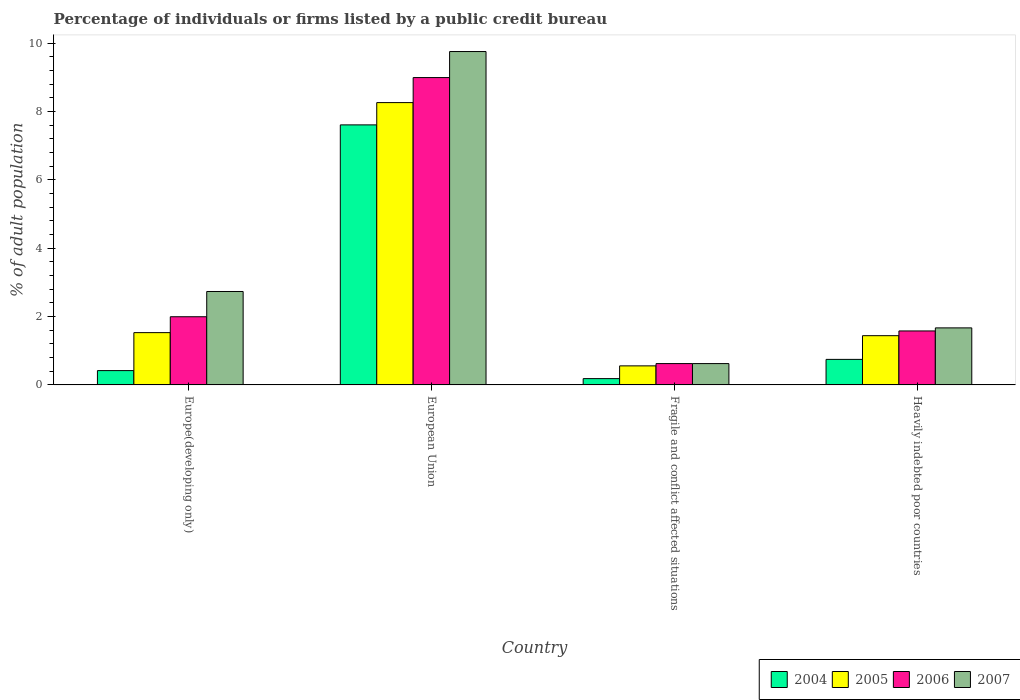How many different coloured bars are there?
Your answer should be very brief. 4. Are the number of bars per tick equal to the number of legend labels?
Your answer should be compact. Yes. What is the label of the 1st group of bars from the left?
Provide a succinct answer. Europe(developing only). What is the percentage of population listed by a public credit bureau in 2007 in Europe(developing only)?
Your response must be concise. 2.73. Across all countries, what is the maximum percentage of population listed by a public credit bureau in 2005?
Offer a very short reply. 8.26. Across all countries, what is the minimum percentage of population listed by a public credit bureau in 2004?
Keep it short and to the point. 0.18. In which country was the percentage of population listed by a public credit bureau in 2007 minimum?
Provide a succinct answer. Fragile and conflict affected situations. What is the total percentage of population listed by a public credit bureau in 2006 in the graph?
Offer a very short reply. 13.19. What is the difference between the percentage of population listed by a public credit bureau in 2005 in Europe(developing only) and that in Fragile and conflict affected situations?
Make the answer very short. 0.97. What is the difference between the percentage of population listed by a public credit bureau in 2007 in Europe(developing only) and the percentage of population listed by a public credit bureau in 2005 in European Union?
Your answer should be compact. -5.53. What is the average percentage of population listed by a public credit bureau in 2006 per country?
Offer a very short reply. 3.3. What is the difference between the percentage of population listed by a public credit bureau of/in 2005 and percentage of population listed by a public credit bureau of/in 2007 in European Union?
Your answer should be compact. -1.49. What is the ratio of the percentage of population listed by a public credit bureau in 2005 in Europe(developing only) to that in European Union?
Your answer should be compact. 0.19. Is the difference between the percentage of population listed by a public credit bureau in 2005 in European Union and Heavily indebted poor countries greater than the difference between the percentage of population listed by a public credit bureau in 2007 in European Union and Heavily indebted poor countries?
Provide a succinct answer. No. What is the difference between the highest and the second highest percentage of population listed by a public credit bureau in 2004?
Provide a succinct answer. 0.33. What is the difference between the highest and the lowest percentage of population listed by a public credit bureau in 2006?
Keep it short and to the point. 8.37. In how many countries, is the percentage of population listed by a public credit bureau in 2006 greater than the average percentage of population listed by a public credit bureau in 2006 taken over all countries?
Provide a short and direct response. 1. Is the sum of the percentage of population listed by a public credit bureau in 2005 in Fragile and conflict affected situations and Heavily indebted poor countries greater than the maximum percentage of population listed by a public credit bureau in 2007 across all countries?
Make the answer very short. No. What does the 2nd bar from the left in European Union represents?
Keep it short and to the point. 2005. What does the 3rd bar from the right in Europe(developing only) represents?
Offer a terse response. 2005. Is it the case that in every country, the sum of the percentage of population listed by a public credit bureau in 2005 and percentage of population listed by a public credit bureau in 2007 is greater than the percentage of population listed by a public credit bureau in 2006?
Ensure brevity in your answer.  Yes. How many countries are there in the graph?
Offer a very short reply. 4. What is the difference between two consecutive major ticks on the Y-axis?
Provide a succinct answer. 2. Does the graph contain any zero values?
Provide a succinct answer. No. Where does the legend appear in the graph?
Your response must be concise. Bottom right. How are the legend labels stacked?
Your answer should be very brief. Horizontal. What is the title of the graph?
Your answer should be very brief. Percentage of individuals or firms listed by a public credit bureau. What is the label or title of the X-axis?
Keep it short and to the point. Country. What is the label or title of the Y-axis?
Make the answer very short. % of adult population. What is the % of adult population in 2004 in Europe(developing only)?
Your answer should be compact. 0.42. What is the % of adult population in 2005 in Europe(developing only)?
Keep it short and to the point. 1.53. What is the % of adult population of 2006 in Europe(developing only)?
Make the answer very short. 1.99. What is the % of adult population in 2007 in Europe(developing only)?
Ensure brevity in your answer.  2.73. What is the % of adult population in 2004 in European Union?
Give a very brief answer. 7.61. What is the % of adult population in 2005 in European Union?
Offer a very short reply. 8.26. What is the % of adult population in 2006 in European Union?
Offer a very short reply. 8.99. What is the % of adult population of 2007 in European Union?
Provide a short and direct response. 9.75. What is the % of adult population in 2004 in Fragile and conflict affected situations?
Ensure brevity in your answer.  0.18. What is the % of adult population in 2005 in Fragile and conflict affected situations?
Offer a very short reply. 0.56. What is the % of adult population of 2006 in Fragile and conflict affected situations?
Make the answer very short. 0.62. What is the % of adult population of 2007 in Fragile and conflict affected situations?
Your response must be concise. 0.62. What is the % of adult population of 2004 in Heavily indebted poor countries?
Keep it short and to the point. 0.75. What is the % of adult population in 2005 in Heavily indebted poor countries?
Offer a very short reply. 1.44. What is the % of adult population of 2006 in Heavily indebted poor countries?
Offer a very short reply. 1.58. What is the % of adult population of 2007 in Heavily indebted poor countries?
Offer a terse response. 1.67. Across all countries, what is the maximum % of adult population in 2004?
Your answer should be very brief. 7.61. Across all countries, what is the maximum % of adult population of 2005?
Offer a terse response. 8.26. Across all countries, what is the maximum % of adult population of 2006?
Ensure brevity in your answer.  8.99. Across all countries, what is the maximum % of adult population of 2007?
Make the answer very short. 9.75. Across all countries, what is the minimum % of adult population of 2004?
Keep it short and to the point. 0.18. Across all countries, what is the minimum % of adult population of 2005?
Offer a terse response. 0.56. Across all countries, what is the minimum % of adult population in 2006?
Ensure brevity in your answer.  0.62. Across all countries, what is the minimum % of adult population of 2007?
Ensure brevity in your answer.  0.62. What is the total % of adult population of 2004 in the graph?
Give a very brief answer. 8.96. What is the total % of adult population of 2005 in the graph?
Give a very brief answer. 11.79. What is the total % of adult population in 2006 in the graph?
Ensure brevity in your answer.  13.19. What is the total % of adult population of 2007 in the graph?
Your answer should be compact. 14.78. What is the difference between the % of adult population in 2004 in Europe(developing only) and that in European Union?
Make the answer very short. -7.19. What is the difference between the % of adult population in 2005 in Europe(developing only) and that in European Union?
Your answer should be very brief. -6.73. What is the difference between the % of adult population in 2006 in Europe(developing only) and that in European Union?
Ensure brevity in your answer.  -7. What is the difference between the % of adult population of 2007 in Europe(developing only) and that in European Union?
Keep it short and to the point. -7.02. What is the difference between the % of adult population in 2004 in Europe(developing only) and that in Fragile and conflict affected situations?
Your response must be concise. 0.23. What is the difference between the % of adult population in 2005 in Europe(developing only) and that in Fragile and conflict affected situations?
Provide a short and direct response. 0.97. What is the difference between the % of adult population in 2006 in Europe(developing only) and that in Fragile and conflict affected situations?
Your answer should be very brief. 1.37. What is the difference between the % of adult population in 2007 in Europe(developing only) and that in Fragile and conflict affected situations?
Ensure brevity in your answer.  2.11. What is the difference between the % of adult population in 2004 in Europe(developing only) and that in Heavily indebted poor countries?
Your response must be concise. -0.33. What is the difference between the % of adult population in 2005 in Europe(developing only) and that in Heavily indebted poor countries?
Provide a succinct answer. 0.09. What is the difference between the % of adult population in 2006 in Europe(developing only) and that in Heavily indebted poor countries?
Provide a succinct answer. 0.42. What is the difference between the % of adult population of 2007 in Europe(developing only) and that in Heavily indebted poor countries?
Keep it short and to the point. 1.06. What is the difference between the % of adult population in 2004 in European Union and that in Fragile and conflict affected situations?
Offer a terse response. 7.42. What is the difference between the % of adult population in 2005 in European Union and that in Fragile and conflict affected situations?
Offer a terse response. 7.7. What is the difference between the % of adult population in 2006 in European Union and that in Fragile and conflict affected situations?
Offer a terse response. 8.37. What is the difference between the % of adult population of 2007 in European Union and that in Fragile and conflict affected situations?
Offer a terse response. 9.13. What is the difference between the % of adult population in 2004 in European Union and that in Heavily indebted poor countries?
Provide a succinct answer. 6.86. What is the difference between the % of adult population in 2005 in European Union and that in Heavily indebted poor countries?
Offer a terse response. 6.82. What is the difference between the % of adult population of 2006 in European Union and that in Heavily indebted poor countries?
Give a very brief answer. 7.41. What is the difference between the % of adult population of 2007 in European Union and that in Heavily indebted poor countries?
Provide a succinct answer. 8.09. What is the difference between the % of adult population in 2004 in Fragile and conflict affected situations and that in Heavily indebted poor countries?
Ensure brevity in your answer.  -0.56. What is the difference between the % of adult population in 2005 in Fragile and conflict affected situations and that in Heavily indebted poor countries?
Make the answer very short. -0.88. What is the difference between the % of adult population of 2006 in Fragile and conflict affected situations and that in Heavily indebted poor countries?
Keep it short and to the point. -0.95. What is the difference between the % of adult population in 2007 in Fragile and conflict affected situations and that in Heavily indebted poor countries?
Keep it short and to the point. -1.04. What is the difference between the % of adult population in 2004 in Europe(developing only) and the % of adult population in 2005 in European Union?
Make the answer very short. -7.84. What is the difference between the % of adult population in 2004 in Europe(developing only) and the % of adult population in 2006 in European Union?
Provide a short and direct response. -8.57. What is the difference between the % of adult population in 2004 in Europe(developing only) and the % of adult population in 2007 in European Union?
Your answer should be compact. -9.34. What is the difference between the % of adult population in 2005 in Europe(developing only) and the % of adult population in 2006 in European Union?
Make the answer very short. -7.46. What is the difference between the % of adult population of 2005 in Europe(developing only) and the % of adult population of 2007 in European Union?
Make the answer very short. -8.22. What is the difference between the % of adult population in 2006 in Europe(developing only) and the % of adult population in 2007 in European Union?
Give a very brief answer. -7.76. What is the difference between the % of adult population of 2004 in Europe(developing only) and the % of adult population of 2005 in Fragile and conflict affected situations?
Keep it short and to the point. -0.14. What is the difference between the % of adult population in 2004 in Europe(developing only) and the % of adult population in 2006 in Fragile and conflict affected situations?
Provide a short and direct response. -0.21. What is the difference between the % of adult population in 2004 in Europe(developing only) and the % of adult population in 2007 in Fragile and conflict affected situations?
Provide a succinct answer. -0.21. What is the difference between the % of adult population in 2005 in Europe(developing only) and the % of adult population in 2006 in Fragile and conflict affected situations?
Provide a short and direct response. 0.91. What is the difference between the % of adult population in 2005 in Europe(developing only) and the % of adult population in 2007 in Fragile and conflict affected situations?
Your answer should be compact. 0.91. What is the difference between the % of adult population of 2006 in Europe(developing only) and the % of adult population of 2007 in Fragile and conflict affected situations?
Keep it short and to the point. 1.37. What is the difference between the % of adult population of 2004 in Europe(developing only) and the % of adult population of 2005 in Heavily indebted poor countries?
Your response must be concise. -1.02. What is the difference between the % of adult population in 2004 in Europe(developing only) and the % of adult population in 2006 in Heavily indebted poor countries?
Your answer should be compact. -1.16. What is the difference between the % of adult population of 2004 in Europe(developing only) and the % of adult population of 2007 in Heavily indebted poor countries?
Make the answer very short. -1.25. What is the difference between the % of adult population in 2005 in Europe(developing only) and the % of adult population in 2006 in Heavily indebted poor countries?
Ensure brevity in your answer.  -0.05. What is the difference between the % of adult population of 2005 in Europe(developing only) and the % of adult population of 2007 in Heavily indebted poor countries?
Give a very brief answer. -0.14. What is the difference between the % of adult population of 2006 in Europe(developing only) and the % of adult population of 2007 in Heavily indebted poor countries?
Offer a terse response. 0.33. What is the difference between the % of adult population of 2004 in European Union and the % of adult population of 2005 in Fragile and conflict affected situations?
Ensure brevity in your answer.  7.05. What is the difference between the % of adult population in 2004 in European Union and the % of adult population in 2006 in Fragile and conflict affected situations?
Your answer should be compact. 6.98. What is the difference between the % of adult population of 2004 in European Union and the % of adult population of 2007 in Fragile and conflict affected situations?
Provide a short and direct response. 6.98. What is the difference between the % of adult population of 2005 in European Union and the % of adult population of 2006 in Fragile and conflict affected situations?
Make the answer very short. 7.64. What is the difference between the % of adult population of 2005 in European Union and the % of adult population of 2007 in Fragile and conflict affected situations?
Offer a very short reply. 7.64. What is the difference between the % of adult population in 2006 in European Union and the % of adult population in 2007 in Fragile and conflict affected situations?
Give a very brief answer. 8.37. What is the difference between the % of adult population of 2004 in European Union and the % of adult population of 2005 in Heavily indebted poor countries?
Ensure brevity in your answer.  6.17. What is the difference between the % of adult population of 2004 in European Union and the % of adult population of 2006 in Heavily indebted poor countries?
Make the answer very short. 6.03. What is the difference between the % of adult population in 2004 in European Union and the % of adult population in 2007 in Heavily indebted poor countries?
Make the answer very short. 5.94. What is the difference between the % of adult population in 2005 in European Union and the % of adult population in 2006 in Heavily indebted poor countries?
Make the answer very short. 6.68. What is the difference between the % of adult population in 2005 in European Union and the % of adult population in 2007 in Heavily indebted poor countries?
Your answer should be compact. 6.59. What is the difference between the % of adult population in 2006 in European Union and the % of adult population in 2007 in Heavily indebted poor countries?
Keep it short and to the point. 7.32. What is the difference between the % of adult population in 2004 in Fragile and conflict affected situations and the % of adult population in 2005 in Heavily indebted poor countries?
Provide a succinct answer. -1.26. What is the difference between the % of adult population in 2004 in Fragile and conflict affected situations and the % of adult population in 2006 in Heavily indebted poor countries?
Your answer should be very brief. -1.39. What is the difference between the % of adult population of 2004 in Fragile and conflict affected situations and the % of adult population of 2007 in Heavily indebted poor countries?
Provide a succinct answer. -1.48. What is the difference between the % of adult population of 2005 in Fragile and conflict affected situations and the % of adult population of 2006 in Heavily indebted poor countries?
Provide a short and direct response. -1.02. What is the difference between the % of adult population of 2005 in Fragile and conflict affected situations and the % of adult population of 2007 in Heavily indebted poor countries?
Provide a short and direct response. -1.11. What is the difference between the % of adult population in 2006 in Fragile and conflict affected situations and the % of adult population in 2007 in Heavily indebted poor countries?
Offer a very short reply. -1.04. What is the average % of adult population in 2004 per country?
Keep it short and to the point. 2.24. What is the average % of adult population of 2005 per country?
Offer a terse response. 2.95. What is the average % of adult population in 2006 per country?
Ensure brevity in your answer.  3.3. What is the average % of adult population of 2007 per country?
Your answer should be compact. 3.69. What is the difference between the % of adult population of 2004 and % of adult population of 2005 in Europe(developing only)?
Your response must be concise. -1.11. What is the difference between the % of adult population in 2004 and % of adult population in 2006 in Europe(developing only)?
Make the answer very short. -1.58. What is the difference between the % of adult population in 2004 and % of adult population in 2007 in Europe(developing only)?
Ensure brevity in your answer.  -2.31. What is the difference between the % of adult population of 2005 and % of adult population of 2006 in Europe(developing only)?
Keep it short and to the point. -0.47. What is the difference between the % of adult population in 2005 and % of adult population in 2007 in Europe(developing only)?
Keep it short and to the point. -1.2. What is the difference between the % of adult population in 2006 and % of adult population in 2007 in Europe(developing only)?
Your answer should be very brief. -0.74. What is the difference between the % of adult population in 2004 and % of adult population in 2005 in European Union?
Give a very brief answer. -0.65. What is the difference between the % of adult population in 2004 and % of adult population in 2006 in European Union?
Give a very brief answer. -1.38. What is the difference between the % of adult population of 2004 and % of adult population of 2007 in European Union?
Your response must be concise. -2.15. What is the difference between the % of adult population in 2005 and % of adult population in 2006 in European Union?
Ensure brevity in your answer.  -0.73. What is the difference between the % of adult population in 2005 and % of adult population in 2007 in European Union?
Offer a terse response. -1.49. What is the difference between the % of adult population of 2006 and % of adult population of 2007 in European Union?
Ensure brevity in your answer.  -0.76. What is the difference between the % of adult population of 2004 and % of adult population of 2005 in Fragile and conflict affected situations?
Your answer should be compact. -0.37. What is the difference between the % of adult population of 2004 and % of adult population of 2006 in Fragile and conflict affected situations?
Your response must be concise. -0.44. What is the difference between the % of adult population of 2004 and % of adult population of 2007 in Fragile and conflict affected situations?
Your response must be concise. -0.44. What is the difference between the % of adult population of 2005 and % of adult population of 2006 in Fragile and conflict affected situations?
Offer a very short reply. -0.07. What is the difference between the % of adult population of 2005 and % of adult population of 2007 in Fragile and conflict affected situations?
Your answer should be compact. -0.07. What is the difference between the % of adult population in 2004 and % of adult population in 2005 in Heavily indebted poor countries?
Provide a short and direct response. -0.69. What is the difference between the % of adult population of 2004 and % of adult population of 2006 in Heavily indebted poor countries?
Make the answer very short. -0.83. What is the difference between the % of adult population in 2004 and % of adult population in 2007 in Heavily indebted poor countries?
Provide a short and direct response. -0.92. What is the difference between the % of adult population in 2005 and % of adult population in 2006 in Heavily indebted poor countries?
Offer a very short reply. -0.14. What is the difference between the % of adult population in 2005 and % of adult population in 2007 in Heavily indebted poor countries?
Your answer should be very brief. -0.23. What is the difference between the % of adult population of 2006 and % of adult population of 2007 in Heavily indebted poor countries?
Ensure brevity in your answer.  -0.09. What is the ratio of the % of adult population of 2004 in Europe(developing only) to that in European Union?
Your answer should be very brief. 0.06. What is the ratio of the % of adult population of 2005 in Europe(developing only) to that in European Union?
Offer a very short reply. 0.19. What is the ratio of the % of adult population of 2006 in Europe(developing only) to that in European Union?
Give a very brief answer. 0.22. What is the ratio of the % of adult population in 2007 in Europe(developing only) to that in European Union?
Make the answer very short. 0.28. What is the ratio of the % of adult population of 2004 in Europe(developing only) to that in Fragile and conflict affected situations?
Your response must be concise. 2.28. What is the ratio of the % of adult population of 2005 in Europe(developing only) to that in Fragile and conflict affected situations?
Keep it short and to the point. 2.75. What is the ratio of the % of adult population of 2006 in Europe(developing only) to that in Fragile and conflict affected situations?
Make the answer very short. 3.2. What is the ratio of the % of adult population in 2007 in Europe(developing only) to that in Fragile and conflict affected situations?
Your answer should be compact. 4.38. What is the ratio of the % of adult population of 2004 in Europe(developing only) to that in Heavily indebted poor countries?
Ensure brevity in your answer.  0.56. What is the ratio of the % of adult population in 2005 in Europe(developing only) to that in Heavily indebted poor countries?
Provide a succinct answer. 1.06. What is the ratio of the % of adult population in 2006 in Europe(developing only) to that in Heavily indebted poor countries?
Make the answer very short. 1.26. What is the ratio of the % of adult population of 2007 in Europe(developing only) to that in Heavily indebted poor countries?
Give a very brief answer. 1.64. What is the ratio of the % of adult population in 2004 in European Union to that in Fragile and conflict affected situations?
Your answer should be compact. 41.35. What is the ratio of the % of adult population of 2005 in European Union to that in Fragile and conflict affected situations?
Your answer should be very brief. 14.83. What is the ratio of the % of adult population of 2006 in European Union to that in Fragile and conflict affected situations?
Your response must be concise. 14.41. What is the ratio of the % of adult population in 2007 in European Union to that in Fragile and conflict affected situations?
Provide a short and direct response. 15.63. What is the ratio of the % of adult population in 2004 in European Union to that in Heavily indebted poor countries?
Your response must be concise. 10.18. What is the ratio of the % of adult population in 2005 in European Union to that in Heavily indebted poor countries?
Ensure brevity in your answer.  5.73. What is the ratio of the % of adult population in 2006 in European Union to that in Heavily indebted poor countries?
Make the answer very short. 5.7. What is the ratio of the % of adult population in 2007 in European Union to that in Heavily indebted poor countries?
Offer a very short reply. 5.85. What is the ratio of the % of adult population in 2004 in Fragile and conflict affected situations to that in Heavily indebted poor countries?
Ensure brevity in your answer.  0.25. What is the ratio of the % of adult population in 2005 in Fragile and conflict affected situations to that in Heavily indebted poor countries?
Your answer should be very brief. 0.39. What is the ratio of the % of adult population in 2006 in Fragile and conflict affected situations to that in Heavily indebted poor countries?
Offer a very short reply. 0.4. What is the ratio of the % of adult population of 2007 in Fragile and conflict affected situations to that in Heavily indebted poor countries?
Give a very brief answer. 0.37. What is the difference between the highest and the second highest % of adult population in 2004?
Your answer should be compact. 6.86. What is the difference between the highest and the second highest % of adult population of 2005?
Keep it short and to the point. 6.73. What is the difference between the highest and the second highest % of adult population of 2006?
Your answer should be compact. 7. What is the difference between the highest and the second highest % of adult population in 2007?
Give a very brief answer. 7.02. What is the difference between the highest and the lowest % of adult population of 2004?
Provide a succinct answer. 7.42. What is the difference between the highest and the lowest % of adult population in 2005?
Make the answer very short. 7.7. What is the difference between the highest and the lowest % of adult population of 2006?
Offer a terse response. 8.37. What is the difference between the highest and the lowest % of adult population of 2007?
Make the answer very short. 9.13. 